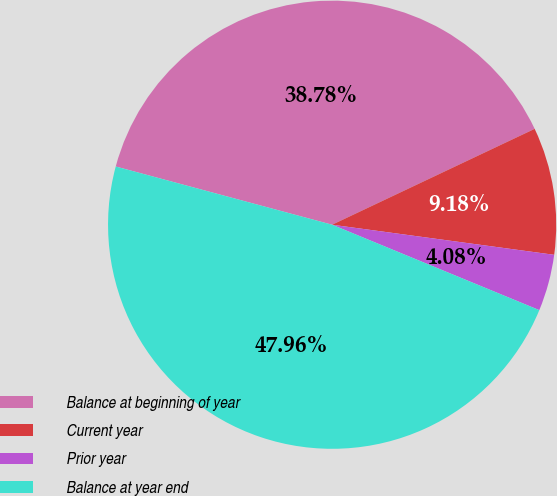Convert chart to OTSL. <chart><loc_0><loc_0><loc_500><loc_500><pie_chart><fcel>Balance at beginning of year<fcel>Current year<fcel>Prior year<fcel>Balance at year end<nl><fcel>38.78%<fcel>9.18%<fcel>4.08%<fcel>47.96%<nl></chart> 